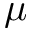<formula> <loc_0><loc_0><loc_500><loc_500>\mu</formula> 